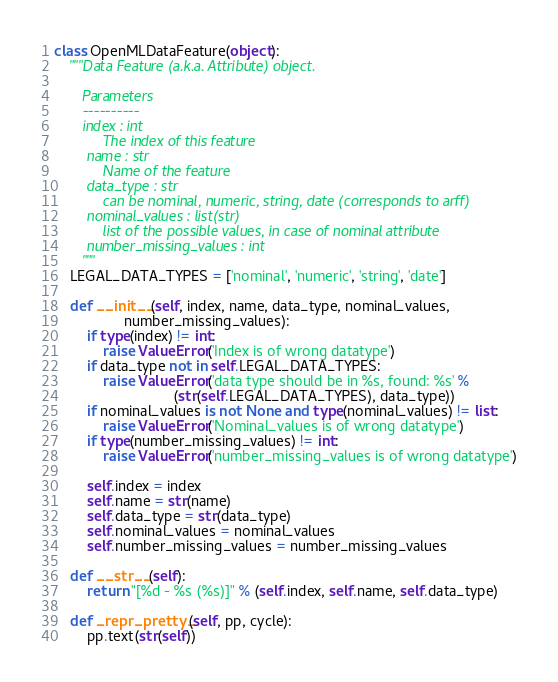Convert code to text. <code><loc_0><loc_0><loc_500><loc_500><_Python_>
class OpenMLDataFeature(object):
    """Data Feature (a.k.a. Attribute) object.

       Parameters
       ----------
       index : int
            The index of this feature
        name : str
            Name of the feature
        data_type : str
            can be nominal, numeric, string, date (corresponds to arff)
        nominal_values : list(str)
            list of the possible values, in case of nominal attribute
        number_missing_values : int
       """
    LEGAL_DATA_TYPES = ['nominal', 'numeric', 'string', 'date']

    def __init__(self, index, name, data_type, nominal_values,
                 number_missing_values):
        if type(index) != int:
            raise ValueError('Index is of wrong datatype')
        if data_type not in self.LEGAL_DATA_TYPES:
            raise ValueError('data type should be in %s, found: %s' %
                             (str(self.LEGAL_DATA_TYPES), data_type))
        if nominal_values is not None and type(nominal_values) != list:
            raise ValueError('Nominal_values is of wrong datatype')
        if type(number_missing_values) != int:
            raise ValueError('number_missing_values is of wrong datatype')

        self.index = index
        self.name = str(name)
        self.data_type = str(data_type)
        self.nominal_values = nominal_values
        self.number_missing_values = number_missing_values

    def __str__(self):
        return "[%d - %s (%s)]" % (self.index, self.name, self.data_type)

    def _repr_pretty_(self, pp, cycle):
        pp.text(str(self))
</code> 